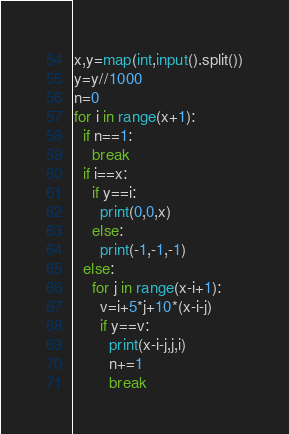<code> <loc_0><loc_0><loc_500><loc_500><_Python_>x,y=map(int,input().split())
y=y//1000
n=0
for i in range(x+1):
  if n==1:
    break
  if i==x:
    if y==i:
      print(0,0,x)
    else:
      print(-1,-1,-1)
  else:
    for j in range(x-i+1):
      v=i+5*j+10*(x-i-j)
      if y==v:
        print(x-i-j,j,i)
        n+=1
        break</code> 